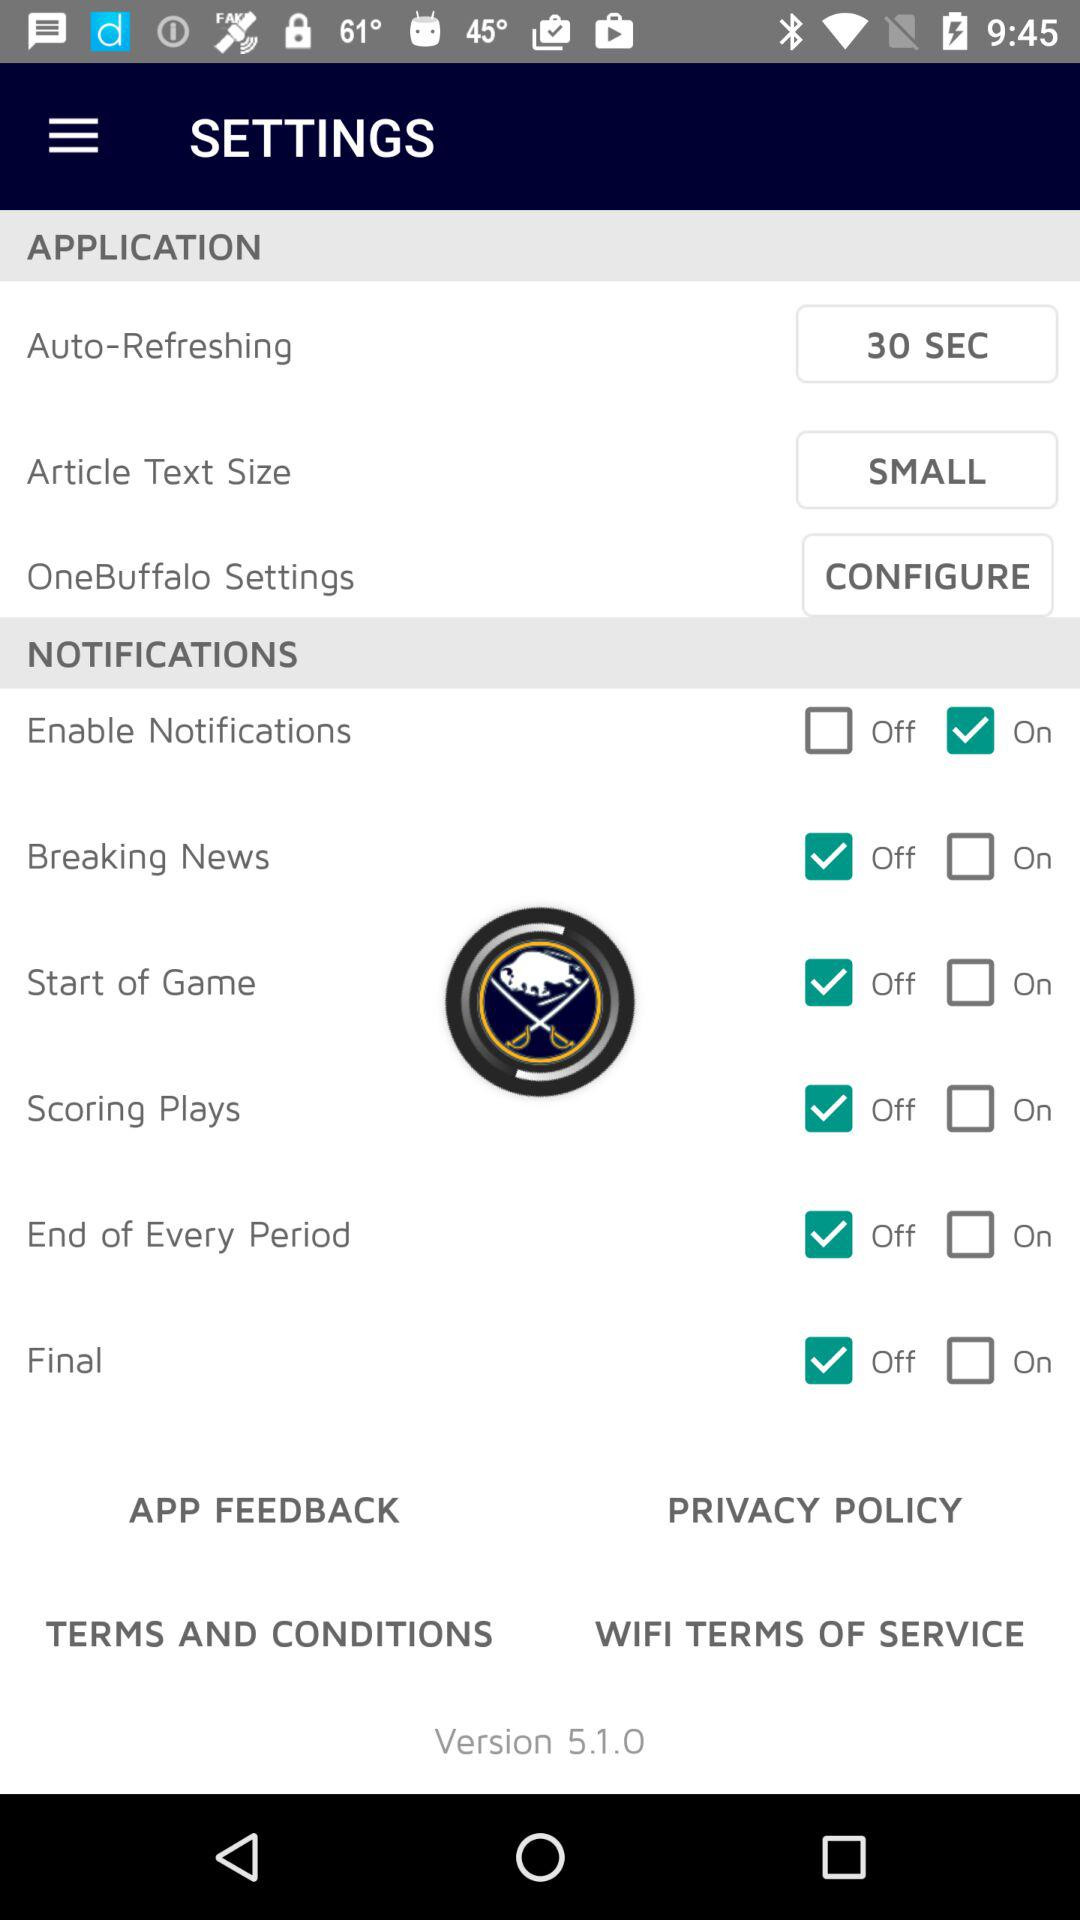What is the auto-refreshing time? The auto-refreshing time is 30 seconds. 